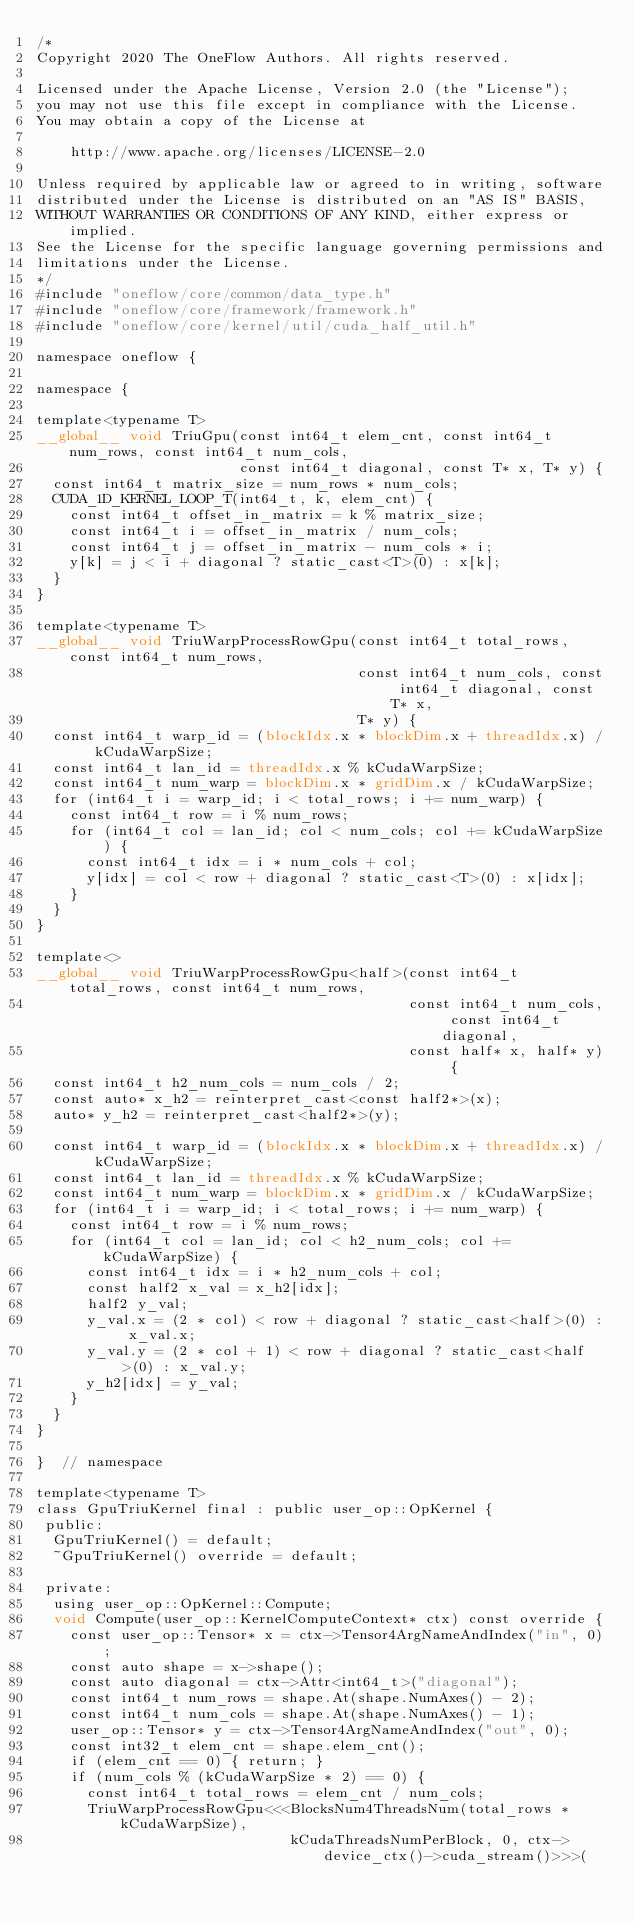<code> <loc_0><loc_0><loc_500><loc_500><_Cuda_>/*
Copyright 2020 The OneFlow Authors. All rights reserved.

Licensed under the Apache License, Version 2.0 (the "License");
you may not use this file except in compliance with the License.
You may obtain a copy of the License at

    http://www.apache.org/licenses/LICENSE-2.0

Unless required by applicable law or agreed to in writing, software
distributed under the License is distributed on an "AS IS" BASIS,
WITHOUT WARRANTIES OR CONDITIONS OF ANY KIND, either express or implied.
See the License for the specific language governing permissions and
limitations under the License.
*/
#include "oneflow/core/common/data_type.h"
#include "oneflow/core/framework/framework.h"
#include "oneflow/core/kernel/util/cuda_half_util.h"

namespace oneflow {

namespace {

template<typename T>
__global__ void TriuGpu(const int64_t elem_cnt, const int64_t num_rows, const int64_t num_cols,
                        const int64_t diagonal, const T* x, T* y) {
  const int64_t matrix_size = num_rows * num_cols;
  CUDA_1D_KERNEL_LOOP_T(int64_t, k, elem_cnt) {
    const int64_t offset_in_matrix = k % matrix_size;
    const int64_t i = offset_in_matrix / num_cols;
    const int64_t j = offset_in_matrix - num_cols * i;
    y[k] = j < i + diagonal ? static_cast<T>(0) : x[k];
  }
}

template<typename T>
__global__ void TriuWarpProcessRowGpu(const int64_t total_rows, const int64_t num_rows,
                                      const int64_t num_cols, const int64_t diagonal, const T* x,
                                      T* y) {
  const int64_t warp_id = (blockIdx.x * blockDim.x + threadIdx.x) / kCudaWarpSize;
  const int64_t lan_id = threadIdx.x % kCudaWarpSize;
  const int64_t num_warp = blockDim.x * gridDim.x / kCudaWarpSize;
  for (int64_t i = warp_id; i < total_rows; i += num_warp) {
    const int64_t row = i % num_rows;
    for (int64_t col = lan_id; col < num_cols; col += kCudaWarpSize) {
      const int64_t idx = i * num_cols + col;
      y[idx] = col < row + diagonal ? static_cast<T>(0) : x[idx];
    }
  }
}

template<>
__global__ void TriuWarpProcessRowGpu<half>(const int64_t total_rows, const int64_t num_rows,
                                            const int64_t num_cols, const int64_t diagonal,
                                            const half* x, half* y) {
  const int64_t h2_num_cols = num_cols / 2;
  const auto* x_h2 = reinterpret_cast<const half2*>(x);
  auto* y_h2 = reinterpret_cast<half2*>(y);

  const int64_t warp_id = (blockIdx.x * blockDim.x + threadIdx.x) / kCudaWarpSize;
  const int64_t lan_id = threadIdx.x % kCudaWarpSize;
  const int64_t num_warp = blockDim.x * gridDim.x / kCudaWarpSize;
  for (int64_t i = warp_id; i < total_rows; i += num_warp) {
    const int64_t row = i % num_rows;
    for (int64_t col = lan_id; col < h2_num_cols; col += kCudaWarpSize) {
      const int64_t idx = i * h2_num_cols + col;
      const half2 x_val = x_h2[idx];
      half2 y_val;
      y_val.x = (2 * col) < row + diagonal ? static_cast<half>(0) : x_val.x;
      y_val.y = (2 * col + 1) < row + diagonal ? static_cast<half>(0) : x_val.y;
      y_h2[idx] = y_val;
    }
  }
}

}  // namespace

template<typename T>
class GpuTriuKernel final : public user_op::OpKernel {
 public:
  GpuTriuKernel() = default;
  ~GpuTriuKernel() override = default;

 private:
  using user_op::OpKernel::Compute;
  void Compute(user_op::KernelComputeContext* ctx) const override {
    const user_op::Tensor* x = ctx->Tensor4ArgNameAndIndex("in", 0);
    const auto shape = x->shape();
    const auto diagonal = ctx->Attr<int64_t>("diagonal");
    const int64_t num_rows = shape.At(shape.NumAxes() - 2);
    const int64_t num_cols = shape.At(shape.NumAxes() - 1);
    user_op::Tensor* y = ctx->Tensor4ArgNameAndIndex("out", 0);
    const int32_t elem_cnt = shape.elem_cnt();
    if (elem_cnt == 0) { return; }
    if (num_cols % (kCudaWarpSize * 2) == 0) {
      const int64_t total_rows = elem_cnt / num_cols;
      TriuWarpProcessRowGpu<<<BlocksNum4ThreadsNum(total_rows * kCudaWarpSize),
                              kCudaThreadsNumPerBlock, 0, ctx->device_ctx()->cuda_stream()>>>(</code> 